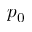Convert formula to latex. <formula><loc_0><loc_0><loc_500><loc_500>p _ { 0 }</formula> 